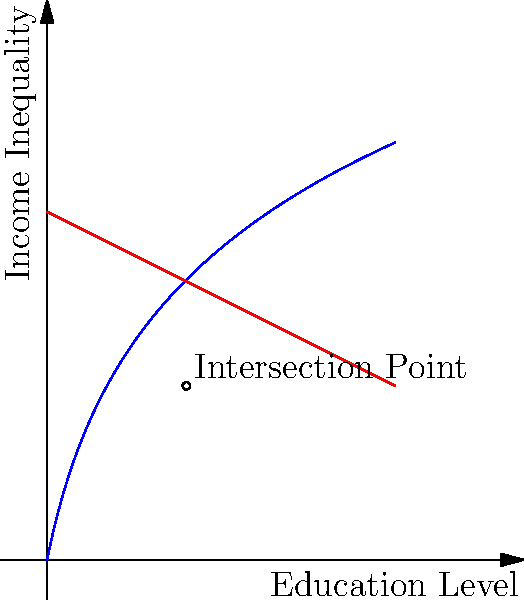Consider the graph above, where the blue curve represents income inequality as a function of education level, and the red line represents a decreasing trend in education level over time. At the intersection point of these two curves, what is the rate of change of income inequality with respect to education level? To find the rate of change of income inequality with respect to education level at the intersection point, we need to follow these steps:

1. Identify the functions:
   Blue curve (income inequality): $f(x) = 5\ln(x+1)$
   Red line (education level): $g(x) = 10 - 0.5x$

2. Find the intersection point:
   Set $f(x) = g(x)$
   $5\ln(x+1) = 10 - 0.5x$
   Solving this equation numerically gives us $x \approx 4$

3. Calculate the derivative of $f(x)$:
   $f'(x) = \frac{5}{x+1}$

4. Evaluate the derivative at the intersection point:
   $f'(4) = \frac{5}{4+1} = 1$

Therefore, at the intersection point, the rate of change of income inequality with respect to education level is 1.
Answer: 1 